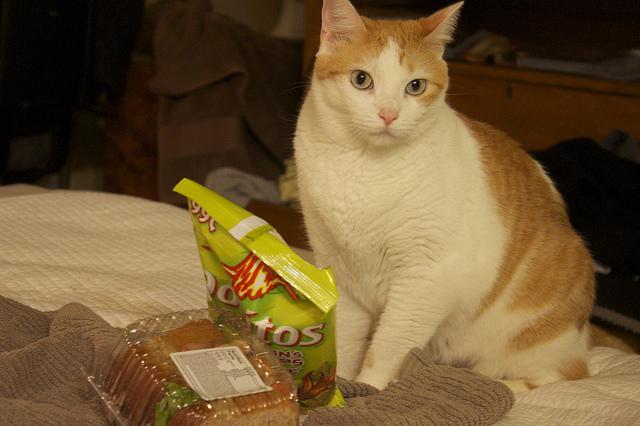How many animals are in this photo?
Concise answer only. 1. What is the object to the left of the cat?
Keep it brief. Food. Does it appear to be two cats?
Write a very short answer. No. What brand chips is near the cat?
Concise answer only. Doritos. Why is the cat sitting there?
Concise answer only. Forrest. How many cats can you see?
Give a very brief answer. 1. What is the person feeding the cat?
Give a very brief answer. Doritos. What is the cat on top of?
Write a very short answer. Bed. What color is the cat?
Write a very short answer. White and orange. Is the cat eating the chips?
Answer briefly. No. What is this cat doing?
Short answer required. Sitting. Is the kitty awake?
Answer briefly. Yes. Is the cat interested in the food?
Keep it brief. No. Is this an adult cat?
Give a very brief answer. Yes. Is this cats colors black and white?
Give a very brief answer. No. What is the cat sniffing?
Quick response, please. Doritos. Is there a remote control in the picture?
Answer briefly. No. 